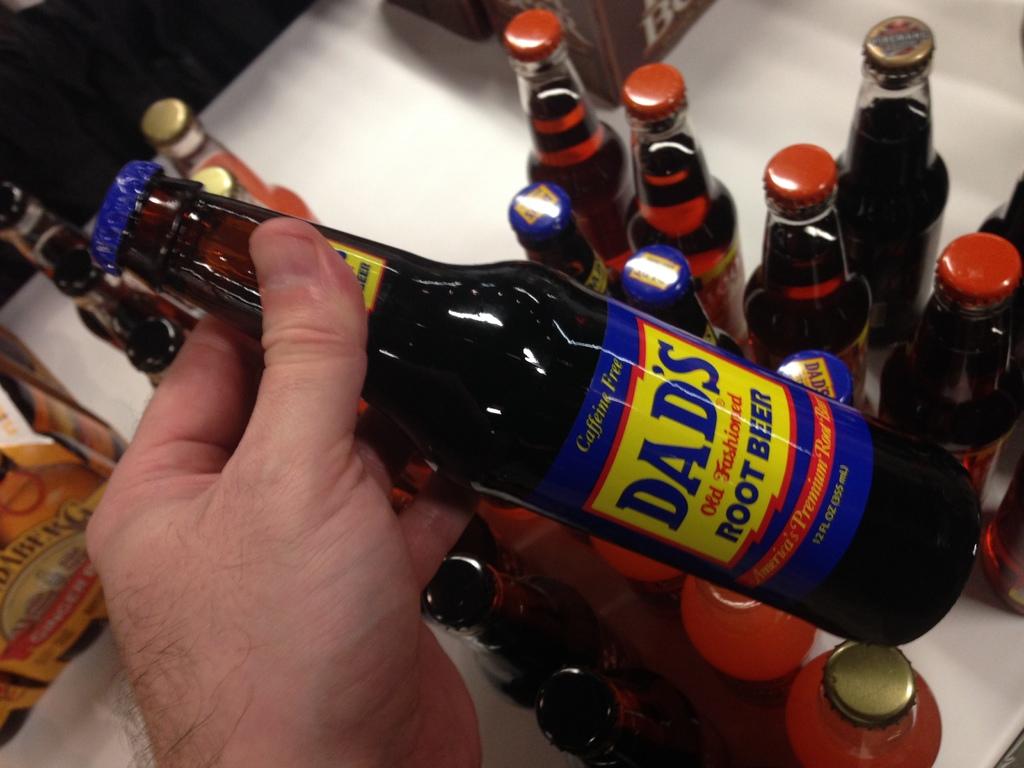What brand of root beer is this?
Offer a very short reply. Dad's. 